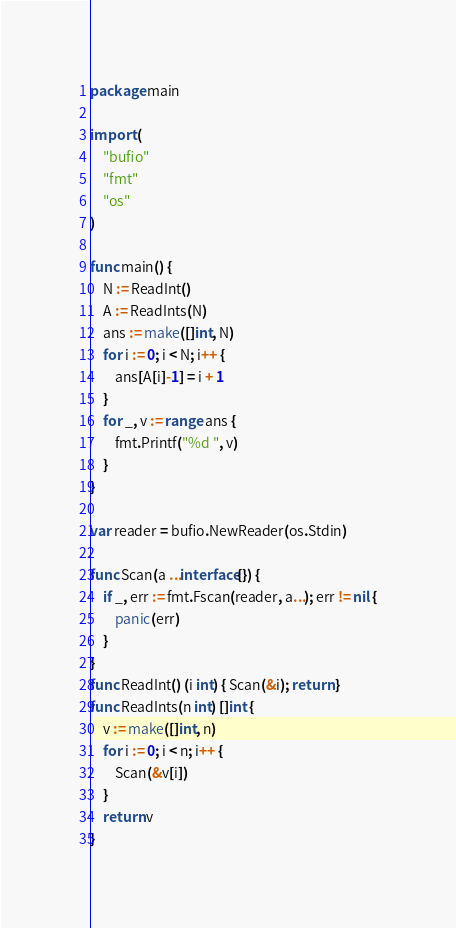Convert code to text. <code><loc_0><loc_0><loc_500><loc_500><_Go_>package main

import (
	"bufio"
	"fmt"
	"os"
)

func main() {
	N := ReadInt()
	A := ReadInts(N)
	ans := make([]int, N)
	for i := 0; i < N; i++ {
		ans[A[i]-1] = i + 1
	}
	for _, v := range ans {
		fmt.Printf("%d ", v)
	}
}

var reader = bufio.NewReader(os.Stdin)

func Scan(a ...interface{}) {
	if _, err := fmt.Fscan(reader, a...); err != nil {
		panic(err)
	}
}
func ReadInt() (i int) { Scan(&i); return }
func ReadInts(n int) []int {
	v := make([]int, n)
	for i := 0; i < n; i++ {
		Scan(&v[i])
	}
	return v
}
</code> 